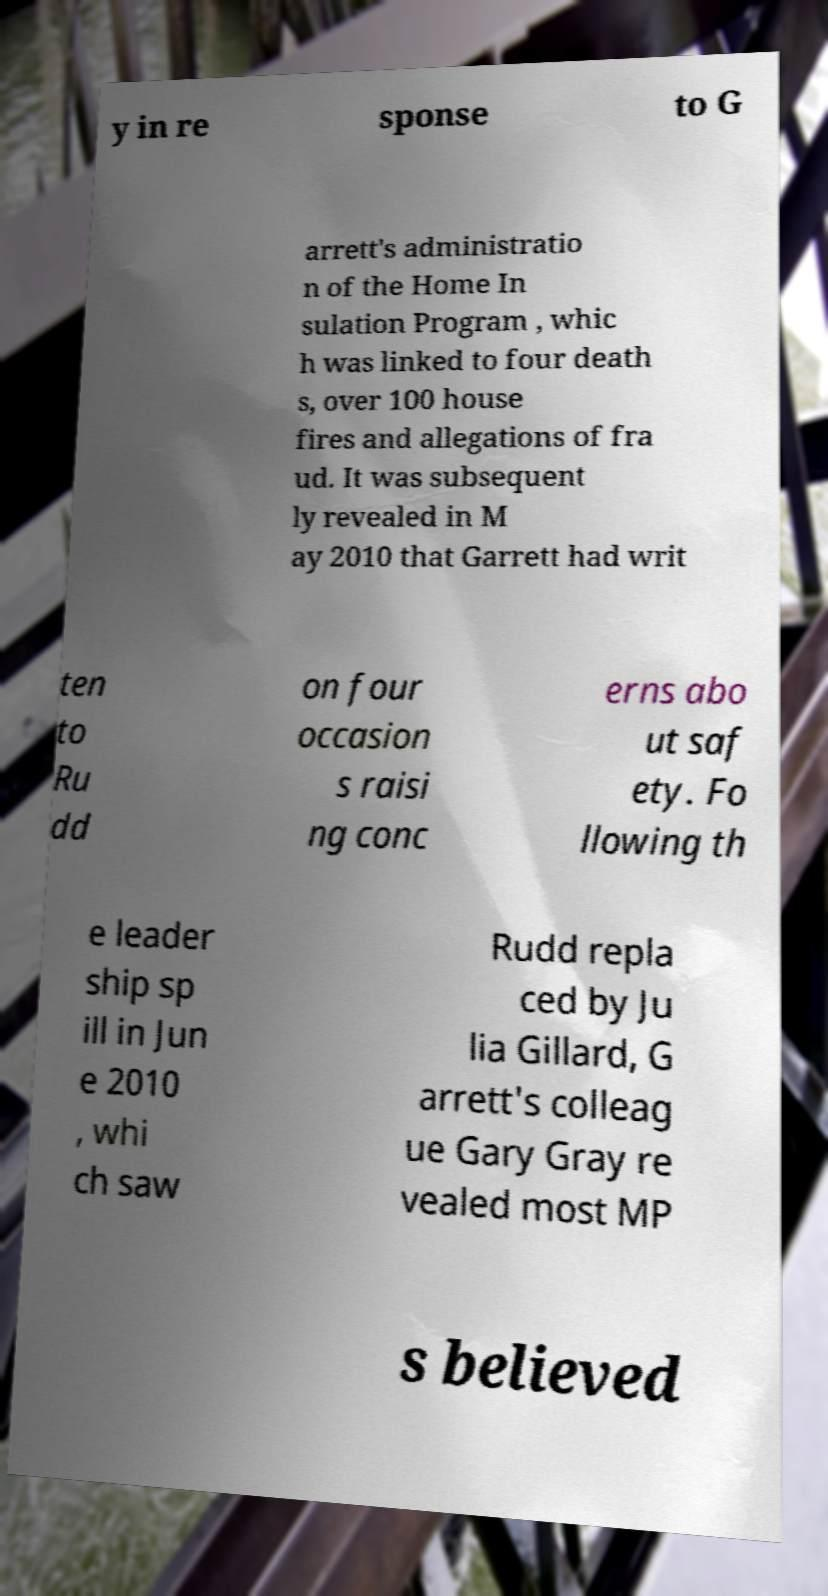Could you assist in decoding the text presented in this image and type it out clearly? y in re sponse to G arrett's administratio n of the Home In sulation Program , whic h was linked to four death s, over 100 house fires and allegations of fra ud. It was subsequent ly revealed in M ay 2010 that Garrett had writ ten to Ru dd on four occasion s raisi ng conc erns abo ut saf ety. Fo llowing th e leader ship sp ill in Jun e 2010 , whi ch saw Rudd repla ced by Ju lia Gillard, G arrett's colleag ue Gary Gray re vealed most MP s believed 